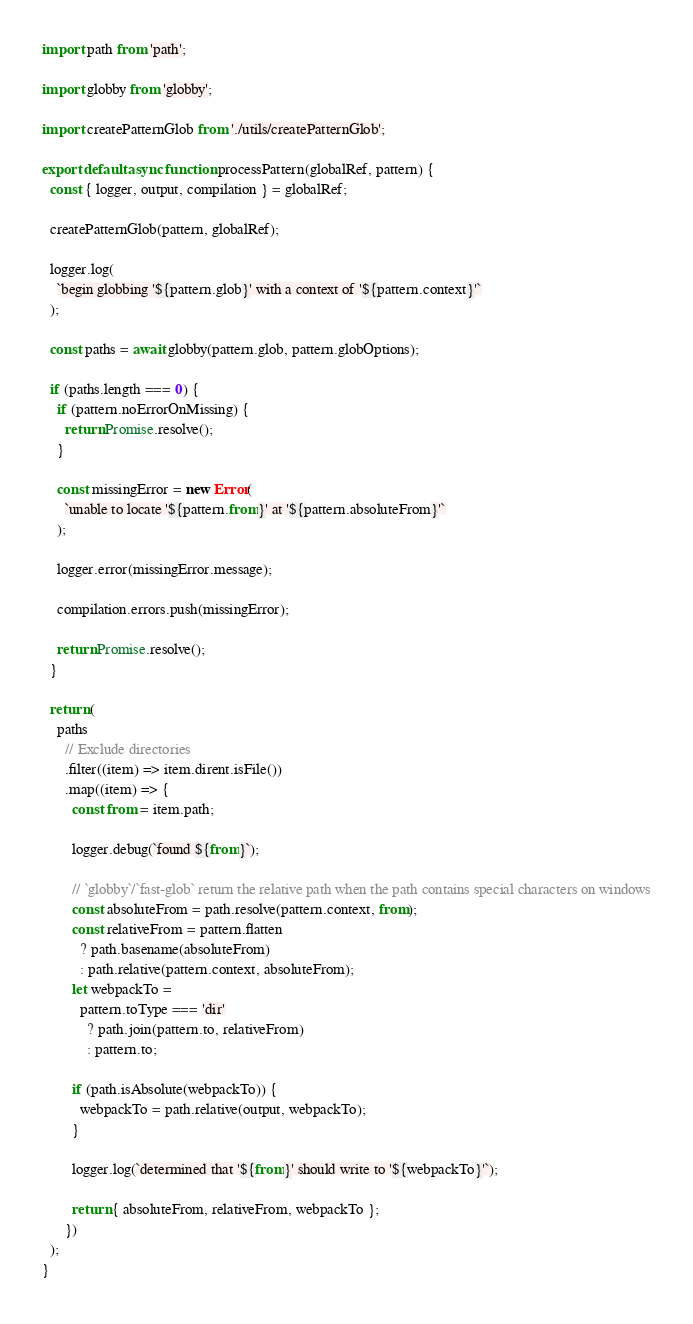<code> <loc_0><loc_0><loc_500><loc_500><_JavaScript_>import path from 'path';

import globby from 'globby';

import createPatternGlob from './utils/createPatternGlob';

export default async function processPattern(globalRef, pattern) {
  const { logger, output, compilation } = globalRef;

  createPatternGlob(pattern, globalRef);

  logger.log(
    `begin globbing '${pattern.glob}' with a context of '${pattern.context}'`
  );

  const paths = await globby(pattern.glob, pattern.globOptions);

  if (paths.length === 0) {
    if (pattern.noErrorOnMissing) {
      return Promise.resolve();
    }

    const missingError = new Error(
      `unable to locate '${pattern.from}' at '${pattern.absoluteFrom}'`
    );

    logger.error(missingError.message);

    compilation.errors.push(missingError);

    return Promise.resolve();
  }

  return (
    paths
      // Exclude directories
      .filter((item) => item.dirent.isFile())
      .map((item) => {
        const from = item.path;

        logger.debug(`found ${from}`);

        // `globby`/`fast-glob` return the relative path when the path contains special characters on windows
        const absoluteFrom = path.resolve(pattern.context, from);
        const relativeFrom = pattern.flatten
          ? path.basename(absoluteFrom)
          : path.relative(pattern.context, absoluteFrom);
        let webpackTo =
          pattern.toType === 'dir'
            ? path.join(pattern.to, relativeFrom)
            : pattern.to;

        if (path.isAbsolute(webpackTo)) {
          webpackTo = path.relative(output, webpackTo);
        }

        logger.log(`determined that '${from}' should write to '${webpackTo}'`);

        return { absoluteFrom, relativeFrom, webpackTo };
      })
  );
}
</code> 